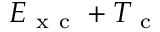Convert formula to latex. <formula><loc_0><loc_0><loc_500><loc_500>E _ { x c } + T _ { c }</formula> 